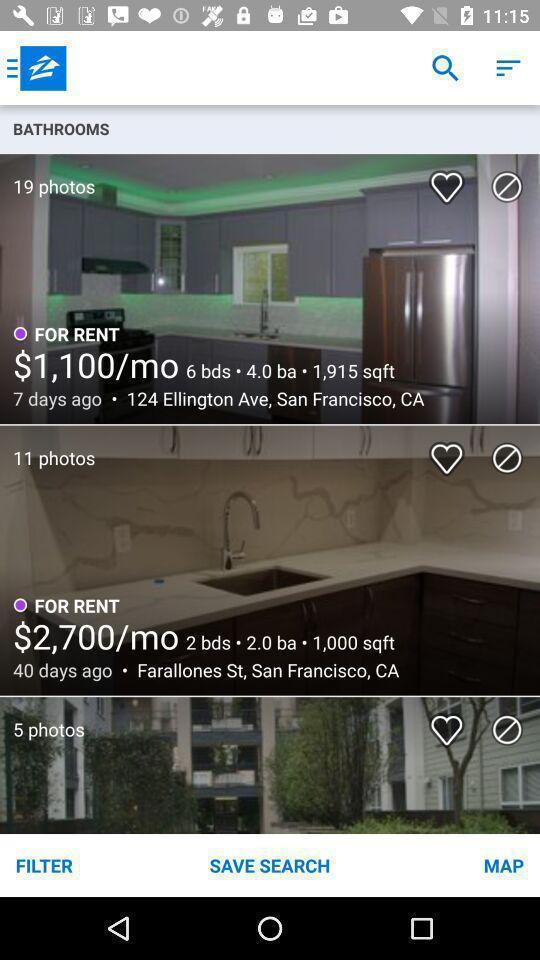Please provide a description for this image. Page showing multiple photos on app. 